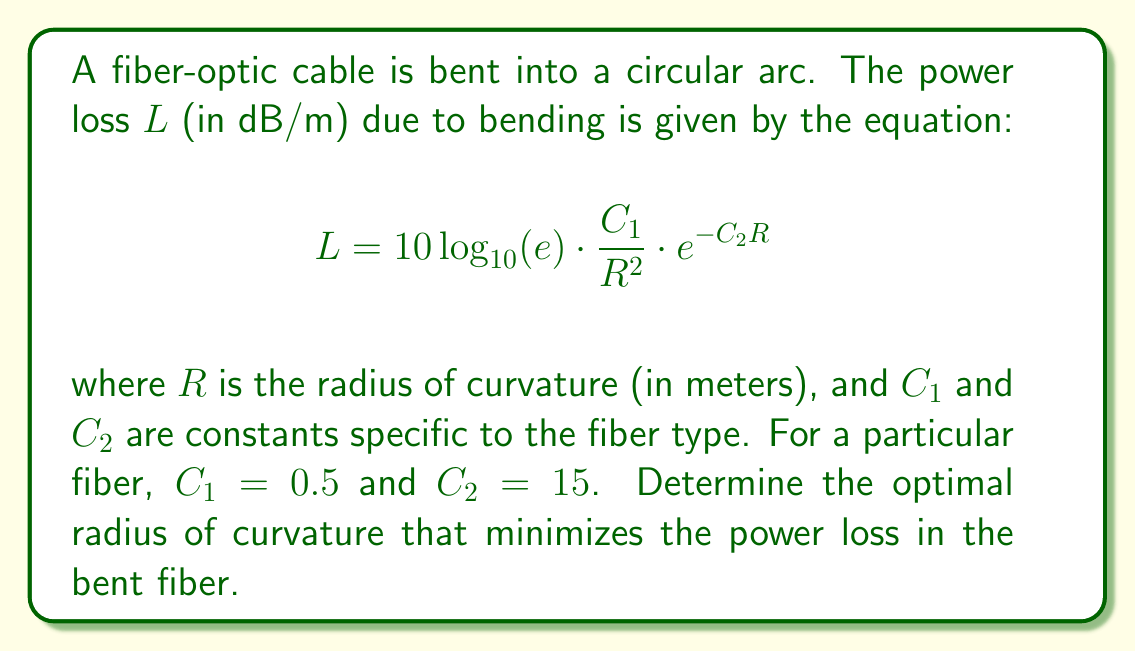Can you solve this math problem? To find the optimal radius of curvature, we need to minimize the power loss function $L$ with respect to $R$. This can be done by finding the derivative of $L$ with respect to $R$ and setting it equal to zero.

1) First, let's simplify the constant term:
   Let $K = 10 \log_{10}(e) \approx 4.343$

2) Now our function becomes:
   $$L = K \cdot \frac{C_1}{R^2} \cdot e^{-C_2R}$$

3) Take the derivative of $L$ with respect to $R$:
   $$\frac{dL}{dR} = K \cdot C_1 \cdot \left(-\frac{2}{R^3}e^{-C_2R} + \frac{1}{R^2}(-C_2)e^{-C_2R}\right)$$

4) Simplify:
   $$\frac{dL}{dR} = K \cdot C_1 \cdot e^{-C_2R} \cdot \left(-\frac{2}{R^3} - \frac{C_2}{R^2}\right)$$

5) Set the derivative equal to zero and solve for $R$:
   $$K \cdot C_1 \cdot e^{-C_2R} \cdot \left(-\frac{2}{R^3} - \frac{C_2}{R^2}\right) = 0$$

   The exponential term is always positive, so we can ignore it. $K$ and $C_1$ are also non-zero constants, so we can divide by them:

   $$-\frac{2}{R^3} - \frac{C_2}{R^2} = 0$$

6) Multiply both sides by $R^3$:
   $$-2 - C_2R = 0$$

7) Solve for $R$:
   $$R = -\frac{2}{C_2}$$

8) Substitute the given value of $C_2 = 15$:
   $$R = -\frac{2}{15} = -\frac{2}{15} \cdot (-1) = \frac{2}{15} \approx 0.1333$$

The negative solution is discarded as the radius of curvature must be positive.

9) Verify this is a minimum by checking the second derivative is positive at this point (omitted for brevity).
Answer: $\frac{2}{15}$ meters 